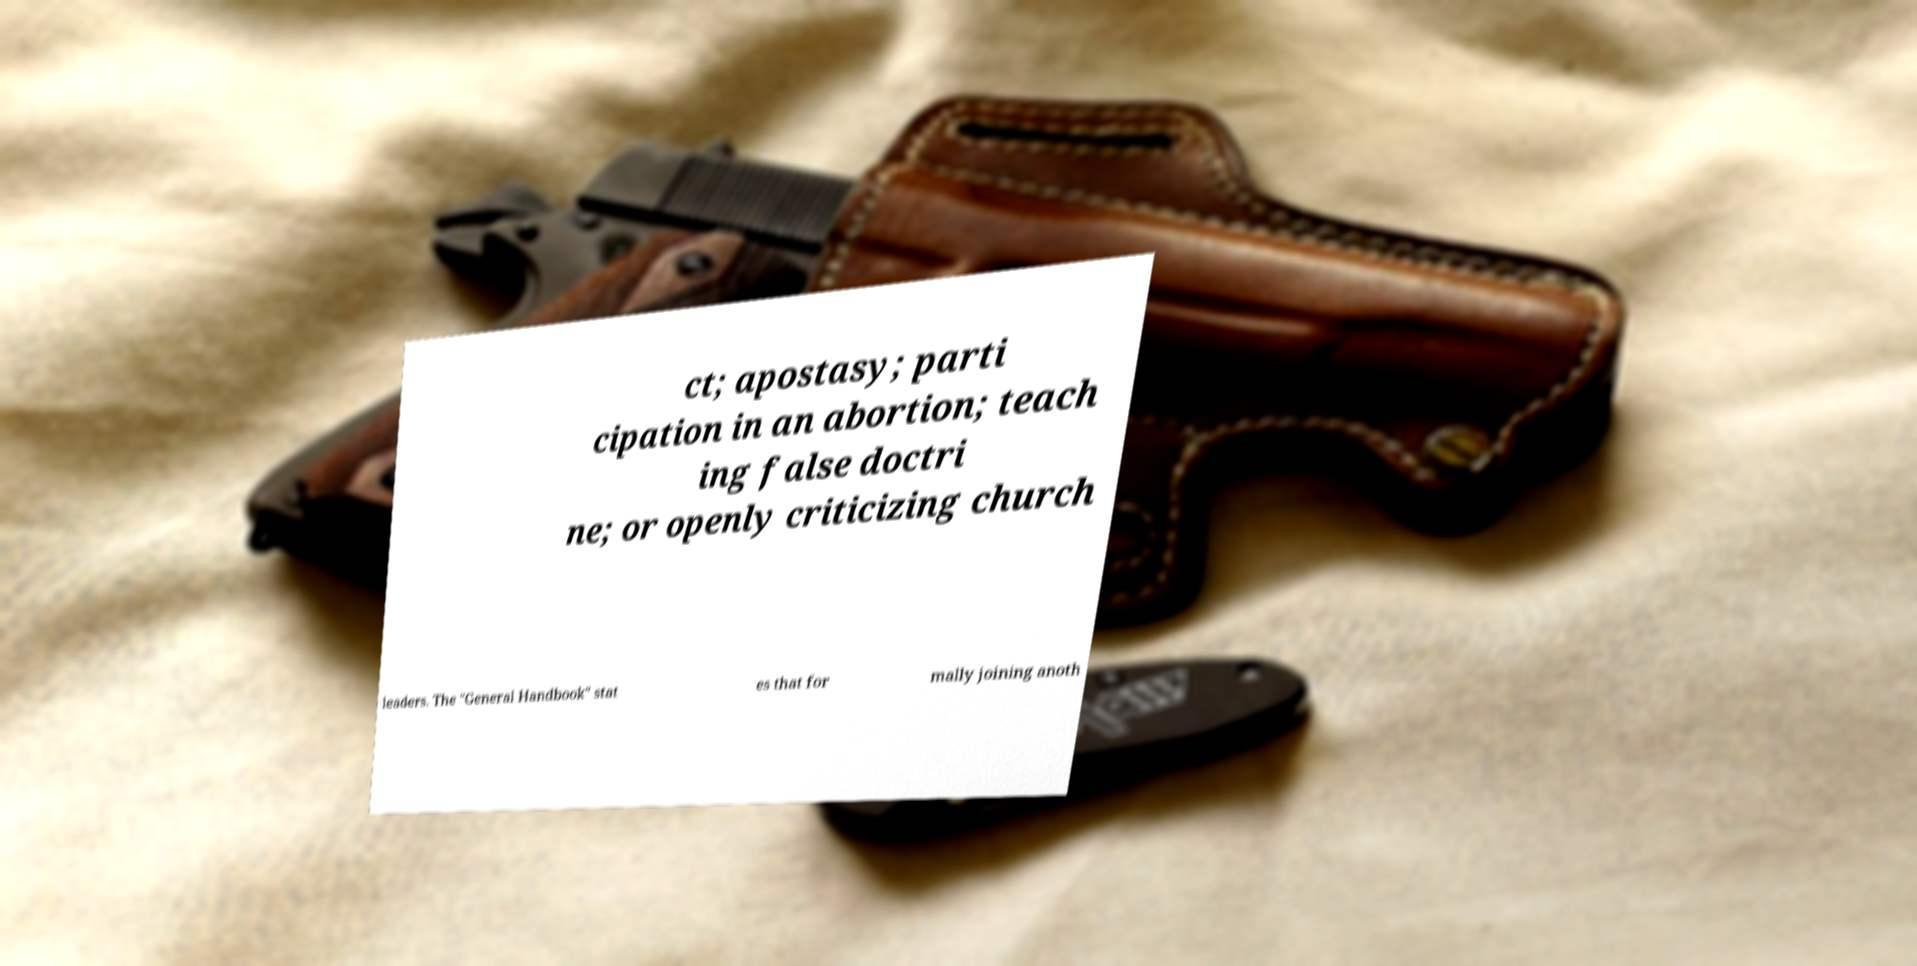Could you extract and type out the text from this image? ct; apostasy; parti cipation in an abortion; teach ing false doctri ne; or openly criticizing church leaders. The "General Handbook" stat es that for mally joining anoth 